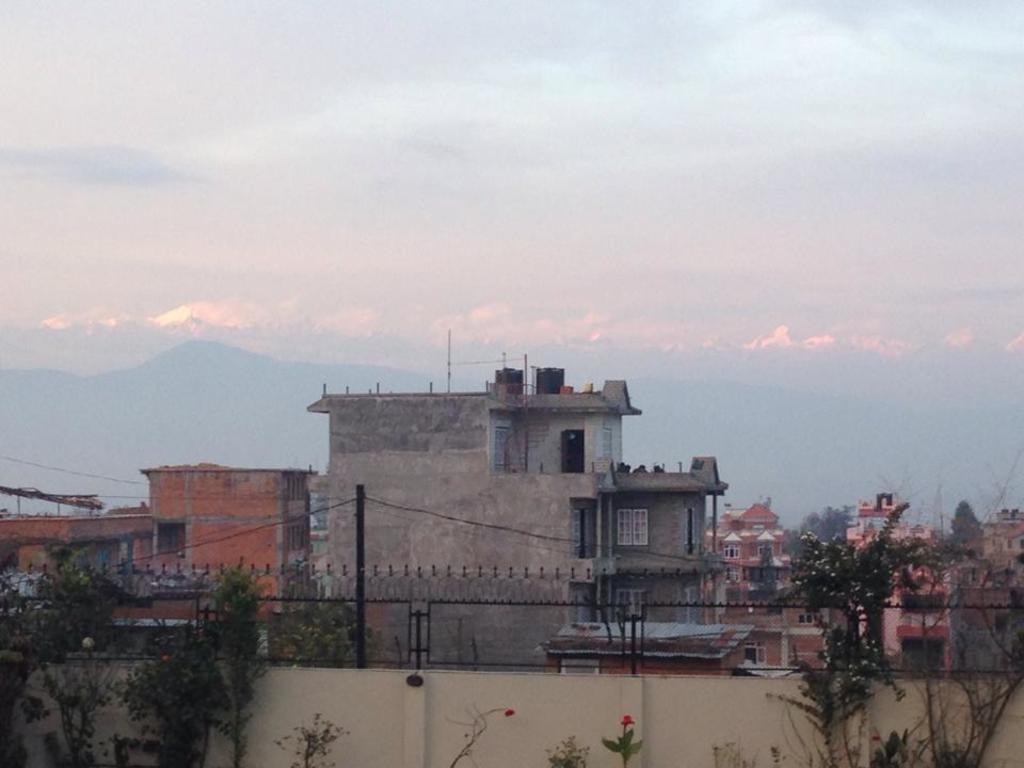Describe this image in one or two sentences. In this image we can see the buildings, trees and also plants. We can also see the wall with the fence. There is a pole with wires. Sky is also visible. 